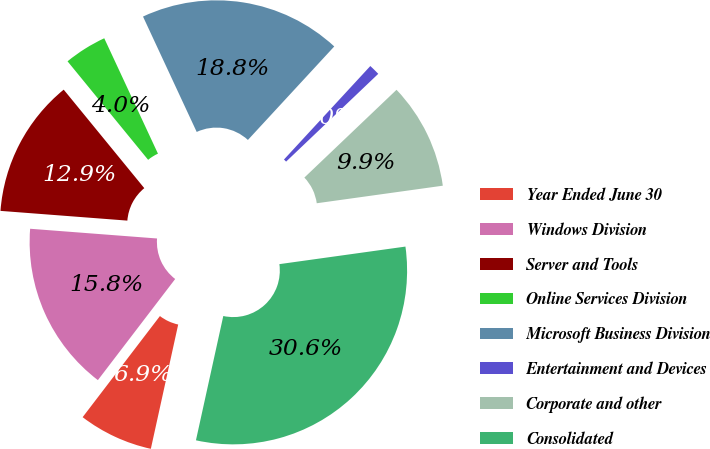<chart> <loc_0><loc_0><loc_500><loc_500><pie_chart><fcel>Year Ended June 30<fcel>Windows Division<fcel>Server and Tools<fcel>Online Services Division<fcel>Microsoft Business Division<fcel>Entertainment and Devices<fcel>Corporate and other<fcel>Consolidated<nl><fcel>6.94%<fcel>15.83%<fcel>12.87%<fcel>3.98%<fcel>18.8%<fcel>1.02%<fcel>9.91%<fcel>30.65%<nl></chart> 